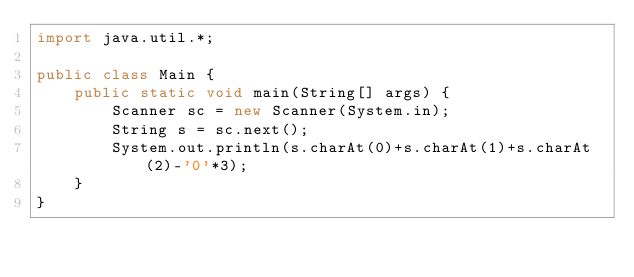<code> <loc_0><loc_0><loc_500><loc_500><_Java_>import java.util.*;

public class Main {
    public static void main(String[] args) {
        Scanner sc = new Scanner(System.in);
        String s = sc.next();
        System.out.println(s.charAt(0)+s.charAt(1)+s.charAt(2)-'0'*3);
    }
}
</code> 